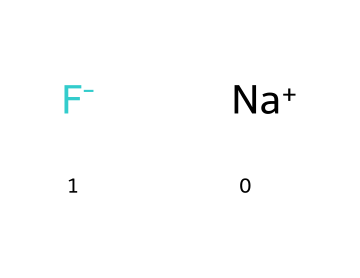What elements are present in this chemical structure? The SMILES representation shows two distinct ions: sodium (Na) and fluoride (F). Therefore, the elements present are sodium and fluorine.
Answer: sodium and fluorine How many atoms are in the chemical structure? Analyzing the SMILES, there is one sodium ion and one fluoride ion, totaling two atoms in the structure.
Answer: two What type of ions are indicated in this chemical? Sodium is a cation (positively charged ion), and fluoride is an anion (negatively charged ion). The structure contains both types of ions, which are typical for salts.
Answer: cation and anion Why is fluoride important for dental health? Fluoride helps in the remineralization of teeth and makes them resistant to decay, which is essential for maintaining oral health, especially for musicians who rely on oral hygiene.
Answer: remineralization What does the presence of fluoride suggest about this chemical's use in dental products? The presence of fluoride indicates that this compound is intended for protective dental health applications, enhancing the tooth's resistance to harmful bacteria and acids.
Answer: protective dental health What is the charge of the fluoride ion in this structure? The SMILES indicates that the fluoride ion is represented as [F-], indicating it has a negative charge.
Answer: negative Is this chemical soluble in water? Sodium fluoride is typically soluble in water, which is useful for its application in dental products, allowing it to effectively provide fluoride benefits to teeth.
Answer: soluble 